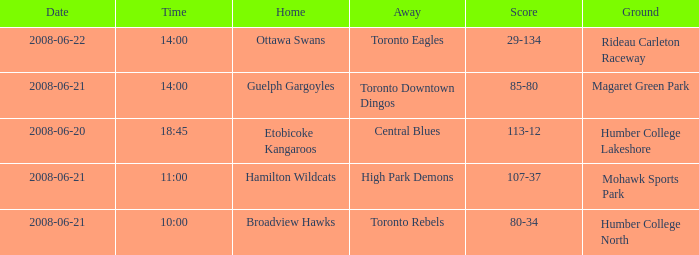What is the ground with a date that is 2008-06-20? Humber College Lakeshore. 